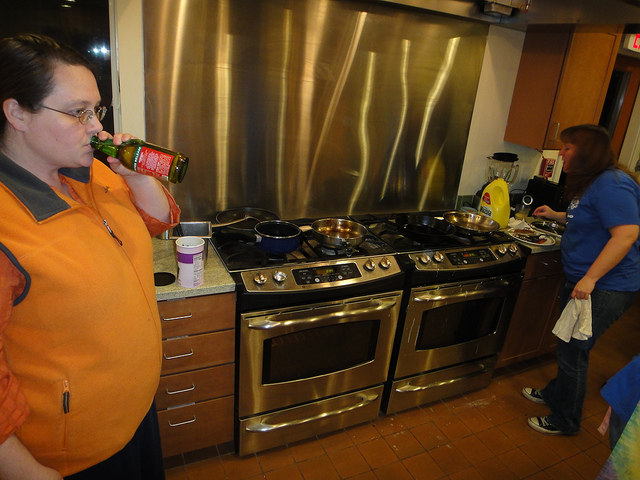<image>What pattern is the woman's shirt? I am not sure about the pattern of the woman's shirt. It could be plain, solid, or orange with black. Where are the portraits? There are no portraits in the image. However, they could potentially be located in another room or out of frame. What vegetable is the man holding? The man is not holding a vegetable in the image. What color are the curtains? It is ambiguous what color the curtains are. They might be gold, silver, or white, but it is also possible that there are no curtains in the picture. What is being made? I don't know what is being made. It can be steak or potentially some sort of dinner. What holiday is this? I don't know exactly what holiday it is, but it could be Thanksgiving, 4th of July or New Year's based on different perspectives. What color is on his shirt? It is ambiguous what color is on his shirt. It might be orange or yellow. What color is the woman's glass frames? I am unsure of the color of the woman's glass frames. The color can be black, orange, brown, green, or silver. What brand is pictured on the shirt of the man wearing orange? I am not sure what brand is pictured on the shirt of the man wearing orange. It could be 'polo', 'nike', 'columbia', 'champion', or 'olympia'. What sport does the girl play? I don't know what sport the girl plays. It could be soccer, bowling, softball or tennis. Does the woman have diabetes? I don't know if the woman has diabetes. It can be either yes or no. Where are the strawberry seeds? I am not sure where the strawberry seeds are. They are not visible in the image. What country is represented in the picture? I don't know what country is represented in the picture. However, it might be the United States. What soft drink brand is the parent company of this water brand? I am not sure, but the parent company of this water brand could be either Pepsi or Coca Cola. What is at the top of the grill? I am not sure what is at the top of the grill. It could be pans, a pan, food, or chicken. Where are the portraits? I don't know where the portraits are. They are not shown in the image. What pattern is the woman's shirt? I am not sure what pattern is the woman's shirt. It can be solid or plain. What vegetable is the man holding? I don't know what vegetable the man is holding. It can be seen that there are both carrots and a beer. What is being made? It is uncertain what is being made. It could be steak or dinner. What color are the curtains? It is ambiguous what color the curtains are. It can be seen 'gold', 'silver', 'white' or 'none'. What color is on his shirt? I am not sure what color is on his shirt. But it can be seen orange. What holiday is this? I am not sure what holiday it is. It can be Thanksgiving, 4th of July, New Year's or birthday. What color is the woman's glass frames? I am not sure what color the woman's glass frames are. It can be seen as black, orange, brown, green, or silver. What brand is pictured on the shirt of the man wearing orange? I am not sure what brand is pictured on the shirt of the man wearing orange. It can be 'polo', 'nike', 'columbia', 'champion', or 'olympia'. What sport does the girl play? It is unknown what sport the girl plays. It can be 'soccer', 'bowling', 'softball' or 'tennis'. Where are the strawberry seeds? It is unclear where the strawberry seeds are. It could be in the strawberry, in the drawer, in the trash, or nowhere. What country is represented in the picture? I don't know which country is represented in the picture. However, it can be guessed to be USA or United States. Does the woman have diabetes? I don't know if the woman has diabetes. It can be both yes or no. What is at the top of the grill? I am not sure what is at the top of the grill. It can be seen pans, pan, food, pots or chicken. What soft drink brand is the parent company of this water brand? I don't know what soft drink brand is the parent company of this water brand. It can be either Pepsi or Coca Cola. 